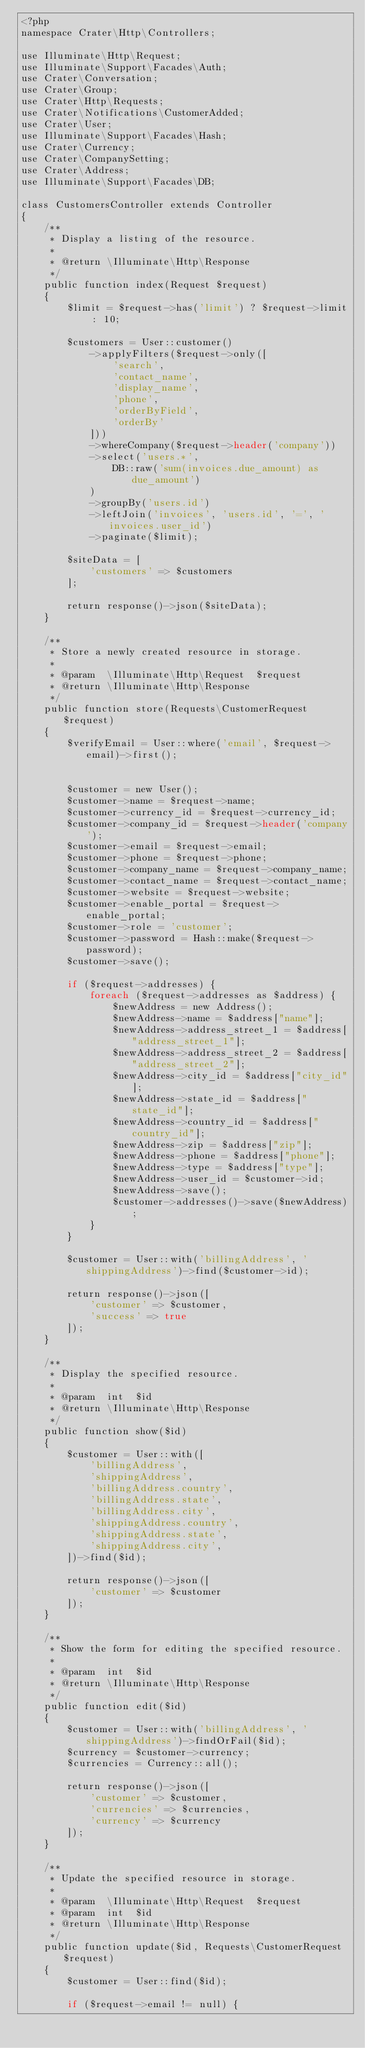Convert code to text. <code><loc_0><loc_0><loc_500><loc_500><_PHP_><?php
namespace Crater\Http\Controllers;

use Illuminate\Http\Request;
use Illuminate\Support\Facades\Auth;
use Crater\Conversation;
use Crater\Group;
use Crater\Http\Requests;
use Crater\Notifications\CustomerAdded;
use Crater\User;
use Illuminate\Support\Facades\Hash;
use Crater\Currency;
use Crater\CompanySetting;
use Crater\Address;
use Illuminate\Support\Facades\DB;

class CustomersController extends Controller
{
    /**
     * Display a listing of the resource.
     *
     * @return \Illuminate\Http\Response
     */
    public function index(Request $request)
    {
        $limit = $request->has('limit') ? $request->limit : 10;

        $customers = User::customer()
            ->applyFilters($request->only([
                'search',
                'contact_name',
                'display_name',
                'phone',
                'orderByField',
                'orderBy'
            ]))
            ->whereCompany($request->header('company'))
            ->select('users.*',
                DB::raw('sum(invoices.due_amount) as due_amount')
            )
            ->groupBy('users.id')
            ->leftJoin('invoices', 'users.id', '=', 'invoices.user_id')
            ->paginate($limit);

        $siteData = [
            'customers' => $customers
        ];

        return response()->json($siteData);
    }

    /**
     * Store a newly created resource in storage.
     *
     * @param  \Illuminate\Http\Request  $request
     * @return \Illuminate\Http\Response
     */
    public function store(Requests\CustomerRequest $request)
    {
        $verifyEmail = User::where('email', $request->email)->first();


        $customer = new User();
        $customer->name = $request->name;
        $customer->currency_id = $request->currency_id;
        $customer->company_id = $request->header('company');
        $customer->email = $request->email;
        $customer->phone = $request->phone;
        $customer->company_name = $request->company_name;
        $customer->contact_name = $request->contact_name;
        $customer->website = $request->website;
        $customer->enable_portal = $request->enable_portal;
        $customer->role = 'customer';
        $customer->password = Hash::make($request->password);
        $customer->save();

        if ($request->addresses) {
            foreach ($request->addresses as $address) {
                $newAddress = new Address();
                $newAddress->name = $address["name"];
                $newAddress->address_street_1 = $address["address_street_1"];
                $newAddress->address_street_2 = $address["address_street_2"];
                $newAddress->city_id = $address["city_id"];
                $newAddress->state_id = $address["state_id"];
                $newAddress->country_id = $address["country_id"];
                $newAddress->zip = $address["zip"];
                $newAddress->phone = $address["phone"];
                $newAddress->type = $address["type"];
                $newAddress->user_id = $customer->id;
                $newAddress->save();
                $customer->addresses()->save($newAddress);
            }
        }

        $customer = User::with('billingAddress', 'shippingAddress')->find($customer->id);

        return response()->json([
            'customer' => $customer,
            'success' => true
        ]);
    }

    /**
     * Display the specified resource.
     *
     * @param  int  $id
     * @return \Illuminate\Http\Response
     */
    public function show($id)
    {
        $customer = User::with([
            'billingAddress',
            'shippingAddress',
            'billingAddress.country',
            'billingAddress.state',
            'billingAddress.city',
            'shippingAddress.country',
            'shippingAddress.state',
            'shippingAddress.city',
        ])->find($id);

        return response()->json([
            'customer' => $customer
        ]);
    }

    /**
     * Show the form for editing the specified resource.
     *
     * @param  int  $id
     * @return \Illuminate\Http\Response
     */
    public function edit($id)
    {
        $customer = User::with('billingAddress', 'shippingAddress')->findOrFail($id);
        $currency = $customer->currency;
        $currencies = Currency::all();

        return response()->json([
            'customer' => $customer,
            'currencies' => $currencies,
            'currency' => $currency
        ]);
    }

    /**
     * Update the specified resource in storage.
     *
     * @param  \Illuminate\Http\Request  $request
     * @param  int  $id
     * @return \Illuminate\Http\Response
     */
    public function update($id, Requests\CustomerRequest $request)
    {
        $customer = User::find($id);

        if ($request->email != null) {</code> 